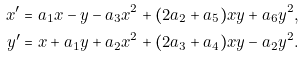<formula> <loc_0><loc_0><loc_500><loc_500>x ^ { \prime } & = a _ { 1 } x - y - a _ { 3 } x ^ { 2 } + ( 2 a _ { 2 } + a _ { 5 } ) x y + a _ { 6 } y ^ { 2 } , \\ y ^ { \prime } & = x + a _ { 1 } y + a _ { 2 } x ^ { 2 } + ( 2 a _ { 3 } + a _ { 4 } ) x y - a _ { 2 } y ^ { 2 } .</formula> 